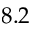<formula> <loc_0><loc_0><loc_500><loc_500>8 . 2</formula> 